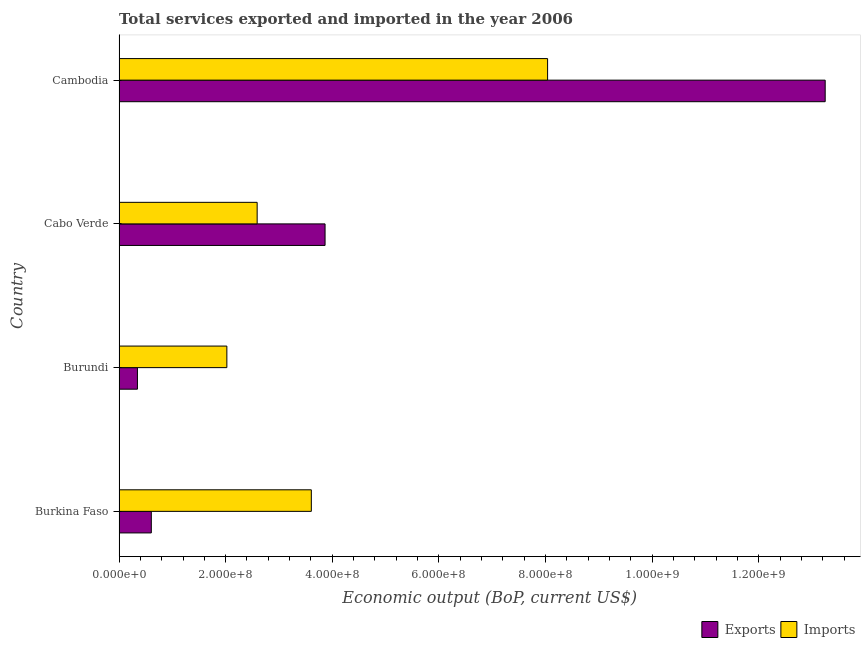How many different coloured bars are there?
Your answer should be compact. 2. Are the number of bars on each tick of the Y-axis equal?
Provide a succinct answer. Yes. How many bars are there on the 4th tick from the top?
Make the answer very short. 2. What is the label of the 4th group of bars from the top?
Offer a terse response. Burkina Faso. What is the amount of service exports in Burkina Faso?
Your answer should be very brief. 6.05e+07. Across all countries, what is the maximum amount of service imports?
Provide a short and direct response. 8.04e+08. Across all countries, what is the minimum amount of service exports?
Provide a short and direct response. 3.45e+07. In which country was the amount of service imports maximum?
Your response must be concise. Cambodia. In which country was the amount of service imports minimum?
Make the answer very short. Burundi. What is the total amount of service exports in the graph?
Give a very brief answer. 1.81e+09. What is the difference between the amount of service imports in Burundi and that in Cambodia?
Your answer should be compact. -6.02e+08. What is the difference between the amount of service exports in Burundi and the amount of service imports in Cabo Verde?
Keep it short and to the point. -2.25e+08. What is the average amount of service imports per country?
Your answer should be very brief. 4.06e+08. What is the difference between the amount of service exports and amount of service imports in Burundi?
Your answer should be very brief. -1.68e+08. In how many countries, is the amount of service exports greater than 1320000000 US$?
Your response must be concise. 1. What is the ratio of the amount of service exports in Burkina Faso to that in Cambodia?
Ensure brevity in your answer.  0.05. Is the difference between the amount of service imports in Burkina Faso and Burundi greater than the difference between the amount of service exports in Burkina Faso and Burundi?
Offer a terse response. Yes. What is the difference between the highest and the second highest amount of service exports?
Your response must be concise. 9.38e+08. What is the difference between the highest and the lowest amount of service imports?
Give a very brief answer. 6.02e+08. Is the sum of the amount of service exports in Burkina Faso and Cabo Verde greater than the maximum amount of service imports across all countries?
Keep it short and to the point. No. What does the 2nd bar from the top in Burundi represents?
Your answer should be very brief. Exports. What does the 2nd bar from the bottom in Burundi represents?
Give a very brief answer. Imports. How many bars are there?
Make the answer very short. 8. How many countries are there in the graph?
Provide a succinct answer. 4. What is the difference between two consecutive major ticks on the X-axis?
Ensure brevity in your answer.  2.00e+08. Are the values on the major ticks of X-axis written in scientific E-notation?
Give a very brief answer. Yes. Does the graph contain any zero values?
Offer a terse response. No. Does the graph contain grids?
Keep it short and to the point. No. How are the legend labels stacked?
Ensure brevity in your answer.  Horizontal. What is the title of the graph?
Your response must be concise. Total services exported and imported in the year 2006. What is the label or title of the X-axis?
Offer a very short reply. Economic output (BoP, current US$). What is the label or title of the Y-axis?
Make the answer very short. Country. What is the Economic output (BoP, current US$) of Exports in Burkina Faso?
Your answer should be compact. 6.05e+07. What is the Economic output (BoP, current US$) of Imports in Burkina Faso?
Provide a succinct answer. 3.61e+08. What is the Economic output (BoP, current US$) of Exports in Burundi?
Keep it short and to the point. 3.45e+07. What is the Economic output (BoP, current US$) in Imports in Burundi?
Provide a short and direct response. 2.02e+08. What is the Economic output (BoP, current US$) in Exports in Cabo Verde?
Provide a short and direct response. 3.86e+08. What is the Economic output (BoP, current US$) of Imports in Cabo Verde?
Ensure brevity in your answer.  2.59e+08. What is the Economic output (BoP, current US$) of Exports in Cambodia?
Make the answer very short. 1.32e+09. What is the Economic output (BoP, current US$) of Imports in Cambodia?
Give a very brief answer. 8.04e+08. Across all countries, what is the maximum Economic output (BoP, current US$) of Exports?
Offer a terse response. 1.32e+09. Across all countries, what is the maximum Economic output (BoP, current US$) of Imports?
Your answer should be very brief. 8.04e+08. Across all countries, what is the minimum Economic output (BoP, current US$) in Exports?
Make the answer very short. 3.45e+07. Across all countries, what is the minimum Economic output (BoP, current US$) in Imports?
Your response must be concise. 2.02e+08. What is the total Economic output (BoP, current US$) of Exports in the graph?
Provide a succinct answer. 1.81e+09. What is the total Economic output (BoP, current US$) of Imports in the graph?
Make the answer very short. 1.63e+09. What is the difference between the Economic output (BoP, current US$) of Exports in Burkina Faso and that in Burundi?
Offer a terse response. 2.60e+07. What is the difference between the Economic output (BoP, current US$) of Imports in Burkina Faso and that in Burundi?
Provide a short and direct response. 1.58e+08. What is the difference between the Economic output (BoP, current US$) of Exports in Burkina Faso and that in Cabo Verde?
Your response must be concise. -3.26e+08. What is the difference between the Economic output (BoP, current US$) of Imports in Burkina Faso and that in Cabo Verde?
Offer a terse response. 1.02e+08. What is the difference between the Economic output (BoP, current US$) in Exports in Burkina Faso and that in Cambodia?
Offer a very short reply. -1.26e+09. What is the difference between the Economic output (BoP, current US$) of Imports in Burkina Faso and that in Cambodia?
Keep it short and to the point. -4.43e+08. What is the difference between the Economic output (BoP, current US$) in Exports in Burundi and that in Cabo Verde?
Give a very brief answer. -3.52e+08. What is the difference between the Economic output (BoP, current US$) of Imports in Burundi and that in Cabo Verde?
Give a very brief answer. -5.68e+07. What is the difference between the Economic output (BoP, current US$) of Exports in Burundi and that in Cambodia?
Give a very brief answer. -1.29e+09. What is the difference between the Economic output (BoP, current US$) of Imports in Burundi and that in Cambodia?
Give a very brief answer. -6.02e+08. What is the difference between the Economic output (BoP, current US$) of Exports in Cabo Verde and that in Cambodia?
Offer a very short reply. -9.38e+08. What is the difference between the Economic output (BoP, current US$) of Imports in Cabo Verde and that in Cambodia?
Your answer should be compact. -5.45e+08. What is the difference between the Economic output (BoP, current US$) of Exports in Burkina Faso and the Economic output (BoP, current US$) of Imports in Burundi?
Offer a terse response. -1.42e+08. What is the difference between the Economic output (BoP, current US$) of Exports in Burkina Faso and the Economic output (BoP, current US$) of Imports in Cabo Verde?
Keep it short and to the point. -1.99e+08. What is the difference between the Economic output (BoP, current US$) of Exports in Burkina Faso and the Economic output (BoP, current US$) of Imports in Cambodia?
Keep it short and to the point. -7.43e+08. What is the difference between the Economic output (BoP, current US$) of Exports in Burundi and the Economic output (BoP, current US$) of Imports in Cabo Verde?
Your response must be concise. -2.25e+08. What is the difference between the Economic output (BoP, current US$) of Exports in Burundi and the Economic output (BoP, current US$) of Imports in Cambodia?
Keep it short and to the point. -7.69e+08. What is the difference between the Economic output (BoP, current US$) in Exports in Cabo Verde and the Economic output (BoP, current US$) in Imports in Cambodia?
Provide a short and direct response. -4.17e+08. What is the average Economic output (BoP, current US$) in Exports per country?
Your answer should be very brief. 4.52e+08. What is the average Economic output (BoP, current US$) of Imports per country?
Offer a very short reply. 4.06e+08. What is the difference between the Economic output (BoP, current US$) of Exports and Economic output (BoP, current US$) of Imports in Burkina Faso?
Your answer should be very brief. -3.00e+08. What is the difference between the Economic output (BoP, current US$) in Exports and Economic output (BoP, current US$) in Imports in Burundi?
Give a very brief answer. -1.68e+08. What is the difference between the Economic output (BoP, current US$) of Exports and Economic output (BoP, current US$) of Imports in Cabo Verde?
Keep it short and to the point. 1.27e+08. What is the difference between the Economic output (BoP, current US$) in Exports and Economic output (BoP, current US$) in Imports in Cambodia?
Your answer should be very brief. 5.21e+08. What is the ratio of the Economic output (BoP, current US$) in Exports in Burkina Faso to that in Burundi?
Your answer should be very brief. 1.75. What is the ratio of the Economic output (BoP, current US$) of Imports in Burkina Faso to that in Burundi?
Provide a succinct answer. 1.78. What is the ratio of the Economic output (BoP, current US$) of Exports in Burkina Faso to that in Cabo Verde?
Keep it short and to the point. 0.16. What is the ratio of the Economic output (BoP, current US$) of Imports in Burkina Faso to that in Cabo Verde?
Your response must be concise. 1.39. What is the ratio of the Economic output (BoP, current US$) in Exports in Burkina Faso to that in Cambodia?
Offer a very short reply. 0.05. What is the ratio of the Economic output (BoP, current US$) of Imports in Burkina Faso to that in Cambodia?
Give a very brief answer. 0.45. What is the ratio of the Economic output (BoP, current US$) in Exports in Burundi to that in Cabo Verde?
Ensure brevity in your answer.  0.09. What is the ratio of the Economic output (BoP, current US$) of Imports in Burundi to that in Cabo Verde?
Ensure brevity in your answer.  0.78. What is the ratio of the Economic output (BoP, current US$) of Exports in Burundi to that in Cambodia?
Offer a terse response. 0.03. What is the ratio of the Economic output (BoP, current US$) in Imports in Burundi to that in Cambodia?
Provide a short and direct response. 0.25. What is the ratio of the Economic output (BoP, current US$) of Exports in Cabo Verde to that in Cambodia?
Your answer should be compact. 0.29. What is the ratio of the Economic output (BoP, current US$) of Imports in Cabo Verde to that in Cambodia?
Your answer should be compact. 0.32. What is the difference between the highest and the second highest Economic output (BoP, current US$) of Exports?
Make the answer very short. 9.38e+08. What is the difference between the highest and the second highest Economic output (BoP, current US$) of Imports?
Your response must be concise. 4.43e+08. What is the difference between the highest and the lowest Economic output (BoP, current US$) of Exports?
Offer a terse response. 1.29e+09. What is the difference between the highest and the lowest Economic output (BoP, current US$) of Imports?
Give a very brief answer. 6.02e+08. 